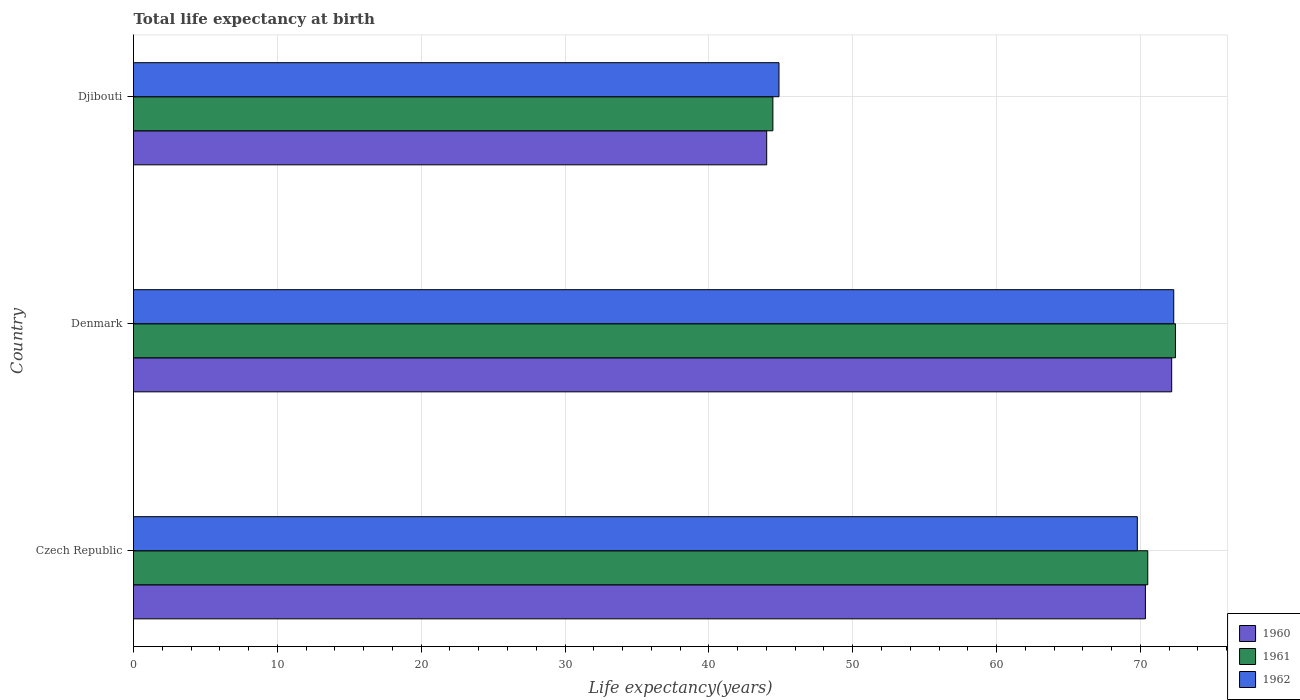How many different coloured bars are there?
Make the answer very short. 3. How many groups of bars are there?
Provide a short and direct response. 3. Are the number of bars per tick equal to the number of legend labels?
Your response must be concise. Yes. How many bars are there on the 1st tick from the top?
Your answer should be compact. 3. How many bars are there on the 1st tick from the bottom?
Ensure brevity in your answer.  3. What is the life expectancy at birth in in 1962 in Denmark?
Provide a succinct answer. 72.32. Across all countries, what is the maximum life expectancy at birth in in 1962?
Ensure brevity in your answer.  72.32. Across all countries, what is the minimum life expectancy at birth in in 1962?
Ensure brevity in your answer.  44.87. In which country was the life expectancy at birth in in 1961 minimum?
Your response must be concise. Djibouti. What is the total life expectancy at birth in in 1962 in the graph?
Make the answer very short. 186.98. What is the difference between the life expectancy at birth in in 1961 in Czech Republic and that in Denmark?
Your answer should be compact. -1.93. What is the difference between the life expectancy at birth in in 1961 in Denmark and the life expectancy at birth in in 1962 in Czech Republic?
Make the answer very short. 2.65. What is the average life expectancy at birth in in 1962 per country?
Provide a short and direct response. 62.33. What is the difference between the life expectancy at birth in in 1960 and life expectancy at birth in in 1962 in Czech Republic?
Provide a short and direct response. 0.56. In how many countries, is the life expectancy at birth in in 1962 greater than 50 years?
Provide a short and direct response. 2. What is the ratio of the life expectancy at birth in in 1960 in Denmark to that in Djibouti?
Make the answer very short. 1.64. Is the life expectancy at birth in in 1960 in Czech Republic less than that in Djibouti?
Your response must be concise. No. Is the difference between the life expectancy at birth in in 1960 in Denmark and Djibouti greater than the difference between the life expectancy at birth in in 1962 in Denmark and Djibouti?
Your response must be concise. Yes. What is the difference between the highest and the second highest life expectancy at birth in in 1961?
Ensure brevity in your answer.  1.93. What is the difference between the highest and the lowest life expectancy at birth in in 1961?
Provide a short and direct response. 27.99. In how many countries, is the life expectancy at birth in in 1962 greater than the average life expectancy at birth in in 1962 taken over all countries?
Offer a very short reply. 2. What does the 1st bar from the bottom in Denmark represents?
Offer a terse response. 1960. Are all the bars in the graph horizontal?
Give a very brief answer. Yes. Does the graph contain any zero values?
Your answer should be very brief. No. Does the graph contain grids?
Provide a succinct answer. Yes. Where does the legend appear in the graph?
Ensure brevity in your answer.  Bottom right. How many legend labels are there?
Give a very brief answer. 3. What is the title of the graph?
Offer a terse response. Total life expectancy at birth. Does "1991" appear as one of the legend labels in the graph?
Make the answer very short. No. What is the label or title of the X-axis?
Ensure brevity in your answer.  Life expectancy(years). What is the Life expectancy(years) of 1960 in Czech Republic?
Your answer should be very brief. 70.35. What is the Life expectancy(years) in 1961 in Czech Republic?
Ensure brevity in your answer.  70.51. What is the Life expectancy(years) in 1962 in Czech Republic?
Offer a very short reply. 69.79. What is the Life expectancy(years) in 1960 in Denmark?
Provide a short and direct response. 72.18. What is the Life expectancy(years) in 1961 in Denmark?
Make the answer very short. 72.44. What is the Life expectancy(years) of 1962 in Denmark?
Give a very brief answer. 72.32. What is the Life expectancy(years) in 1960 in Djibouti?
Provide a short and direct response. 44.02. What is the Life expectancy(years) in 1961 in Djibouti?
Ensure brevity in your answer.  44.45. What is the Life expectancy(years) in 1962 in Djibouti?
Provide a succinct answer. 44.87. Across all countries, what is the maximum Life expectancy(years) of 1960?
Provide a succinct answer. 72.18. Across all countries, what is the maximum Life expectancy(years) of 1961?
Your answer should be very brief. 72.44. Across all countries, what is the maximum Life expectancy(years) in 1962?
Provide a succinct answer. 72.32. Across all countries, what is the minimum Life expectancy(years) in 1960?
Your answer should be very brief. 44.02. Across all countries, what is the minimum Life expectancy(years) of 1961?
Your answer should be very brief. 44.45. Across all countries, what is the minimum Life expectancy(years) in 1962?
Your response must be concise. 44.87. What is the total Life expectancy(years) of 1960 in the graph?
Provide a short and direct response. 186.55. What is the total Life expectancy(years) in 1961 in the graph?
Give a very brief answer. 187.4. What is the total Life expectancy(years) of 1962 in the graph?
Your response must be concise. 186.98. What is the difference between the Life expectancy(years) in 1960 in Czech Republic and that in Denmark?
Give a very brief answer. -1.83. What is the difference between the Life expectancy(years) in 1961 in Czech Republic and that in Denmark?
Your answer should be very brief. -1.93. What is the difference between the Life expectancy(years) in 1962 in Czech Republic and that in Denmark?
Provide a succinct answer. -2.53. What is the difference between the Life expectancy(years) of 1960 in Czech Republic and that in Djibouti?
Provide a succinct answer. 26.33. What is the difference between the Life expectancy(years) in 1961 in Czech Republic and that in Djibouti?
Provide a short and direct response. 26.06. What is the difference between the Life expectancy(years) of 1962 in Czech Republic and that in Djibouti?
Provide a succinct answer. 24.91. What is the difference between the Life expectancy(years) in 1960 in Denmark and that in Djibouti?
Provide a short and direct response. 28.16. What is the difference between the Life expectancy(years) of 1961 in Denmark and that in Djibouti?
Give a very brief answer. 27.99. What is the difference between the Life expectancy(years) in 1962 in Denmark and that in Djibouti?
Offer a terse response. 27.45. What is the difference between the Life expectancy(years) of 1960 in Czech Republic and the Life expectancy(years) of 1961 in Denmark?
Provide a succinct answer. -2.09. What is the difference between the Life expectancy(years) in 1960 in Czech Republic and the Life expectancy(years) in 1962 in Denmark?
Provide a short and direct response. -1.97. What is the difference between the Life expectancy(years) of 1961 in Czech Republic and the Life expectancy(years) of 1962 in Denmark?
Make the answer very short. -1.81. What is the difference between the Life expectancy(years) in 1960 in Czech Republic and the Life expectancy(years) in 1961 in Djibouti?
Your response must be concise. 25.9. What is the difference between the Life expectancy(years) in 1960 in Czech Republic and the Life expectancy(years) in 1962 in Djibouti?
Provide a succinct answer. 25.47. What is the difference between the Life expectancy(years) in 1961 in Czech Republic and the Life expectancy(years) in 1962 in Djibouti?
Offer a terse response. 25.64. What is the difference between the Life expectancy(years) in 1960 in Denmark and the Life expectancy(years) in 1961 in Djibouti?
Offer a very short reply. 27.73. What is the difference between the Life expectancy(years) of 1960 in Denmark and the Life expectancy(years) of 1962 in Djibouti?
Give a very brief answer. 27.3. What is the difference between the Life expectancy(years) in 1961 in Denmark and the Life expectancy(years) in 1962 in Djibouti?
Your answer should be compact. 27.56. What is the average Life expectancy(years) in 1960 per country?
Keep it short and to the point. 62.18. What is the average Life expectancy(years) in 1961 per country?
Your answer should be very brief. 62.47. What is the average Life expectancy(years) of 1962 per country?
Provide a short and direct response. 62.33. What is the difference between the Life expectancy(years) in 1960 and Life expectancy(years) in 1961 in Czech Republic?
Give a very brief answer. -0.16. What is the difference between the Life expectancy(years) of 1960 and Life expectancy(years) of 1962 in Czech Republic?
Your answer should be compact. 0.56. What is the difference between the Life expectancy(years) of 1961 and Life expectancy(years) of 1962 in Czech Republic?
Offer a very short reply. 0.73. What is the difference between the Life expectancy(years) of 1960 and Life expectancy(years) of 1961 in Denmark?
Your answer should be compact. -0.26. What is the difference between the Life expectancy(years) in 1960 and Life expectancy(years) in 1962 in Denmark?
Make the answer very short. -0.14. What is the difference between the Life expectancy(years) of 1961 and Life expectancy(years) of 1962 in Denmark?
Keep it short and to the point. 0.12. What is the difference between the Life expectancy(years) of 1960 and Life expectancy(years) of 1961 in Djibouti?
Give a very brief answer. -0.43. What is the difference between the Life expectancy(years) in 1960 and Life expectancy(years) in 1962 in Djibouti?
Your answer should be very brief. -0.85. What is the difference between the Life expectancy(years) in 1961 and Life expectancy(years) in 1962 in Djibouti?
Give a very brief answer. -0.42. What is the ratio of the Life expectancy(years) of 1960 in Czech Republic to that in Denmark?
Your answer should be compact. 0.97. What is the ratio of the Life expectancy(years) in 1961 in Czech Republic to that in Denmark?
Give a very brief answer. 0.97. What is the ratio of the Life expectancy(years) in 1960 in Czech Republic to that in Djibouti?
Ensure brevity in your answer.  1.6. What is the ratio of the Life expectancy(years) in 1961 in Czech Republic to that in Djibouti?
Keep it short and to the point. 1.59. What is the ratio of the Life expectancy(years) of 1962 in Czech Republic to that in Djibouti?
Keep it short and to the point. 1.56. What is the ratio of the Life expectancy(years) in 1960 in Denmark to that in Djibouti?
Offer a terse response. 1.64. What is the ratio of the Life expectancy(years) in 1961 in Denmark to that in Djibouti?
Give a very brief answer. 1.63. What is the ratio of the Life expectancy(years) in 1962 in Denmark to that in Djibouti?
Offer a terse response. 1.61. What is the difference between the highest and the second highest Life expectancy(years) in 1960?
Your response must be concise. 1.83. What is the difference between the highest and the second highest Life expectancy(years) of 1961?
Give a very brief answer. 1.93. What is the difference between the highest and the second highest Life expectancy(years) in 1962?
Your answer should be compact. 2.53. What is the difference between the highest and the lowest Life expectancy(years) of 1960?
Keep it short and to the point. 28.16. What is the difference between the highest and the lowest Life expectancy(years) of 1961?
Your answer should be very brief. 27.99. What is the difference between the highest and the lowest Life expectancy(years) in 1962?
Your answer should be compact. 27.45. 